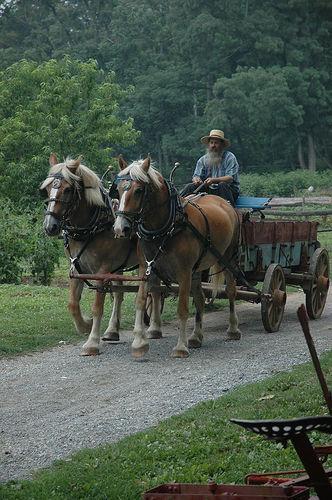How many horses can you see?
Give a very brief answer. 2. 